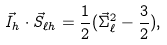Convert formula to latex. <formula><loc_0><loc_0><loc_500><loc_500>\vec { I } _ { h } \cdot \vec { S } _ { \ell h } = \frac { 1 } { 2 } ( \vec { \Sigma } _ { \ell } ^ { 2 } - \frac { 3 } { 2 } ) ,</formula> 